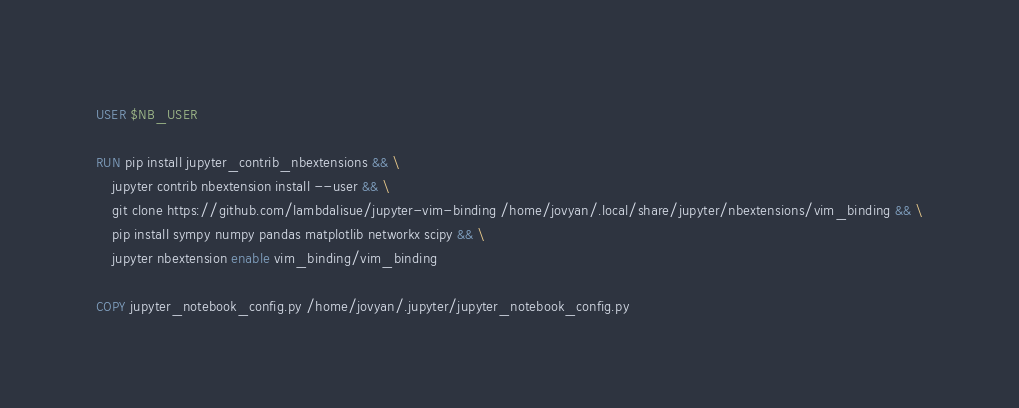<code> <loc_0><loc_0><loc_500><loc_500><_Dockerfile_>USER $NB_USER

RUN pip install jupyter_contrib_nbextensions && \
    jupyter contrib nbextension install --user && \
    git clone https://github.com/lambdalisue/jupyter-vim-binding /home/jovyan/.local/share/jupyter/nbextensions/vim_binding && \
    pip install sympy numpy pandas matplotlib networkx scipy && \
    jupyter nbextension enable vim_binding/vim_binding

COPY jupyter_notebook_config.py /home/jovyan/.jupyter/jupyter_notebook_config.py
</code> 